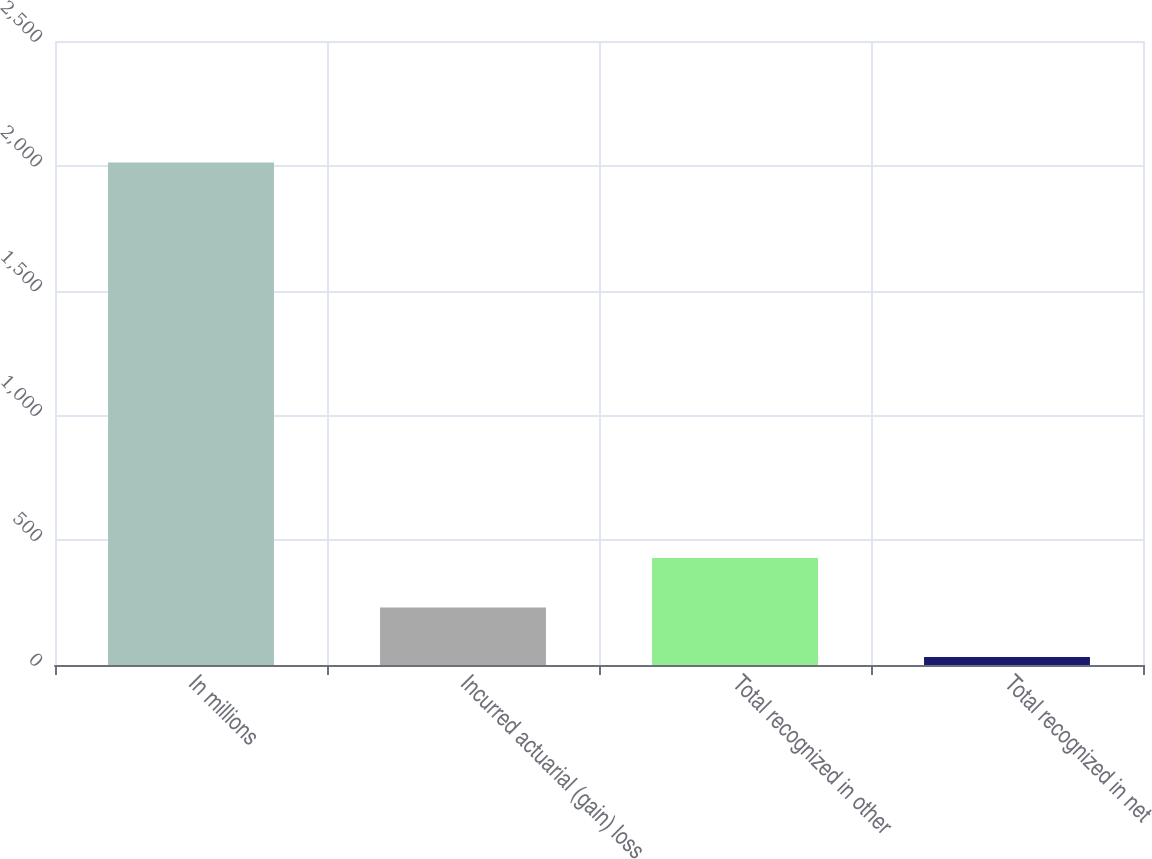Convert chart to OTSL. <chart><loc_0><loc_0><loc_500><loc_500><bar_chart><fcel>In millions<fcel>Incurred actuarial (gain) loss<fcel>Total recognized in other<fcel>Total recognized in net<nl><fcel>2013<fcel>230.1<fcel>428.2<fcel>32<nl></chart> 